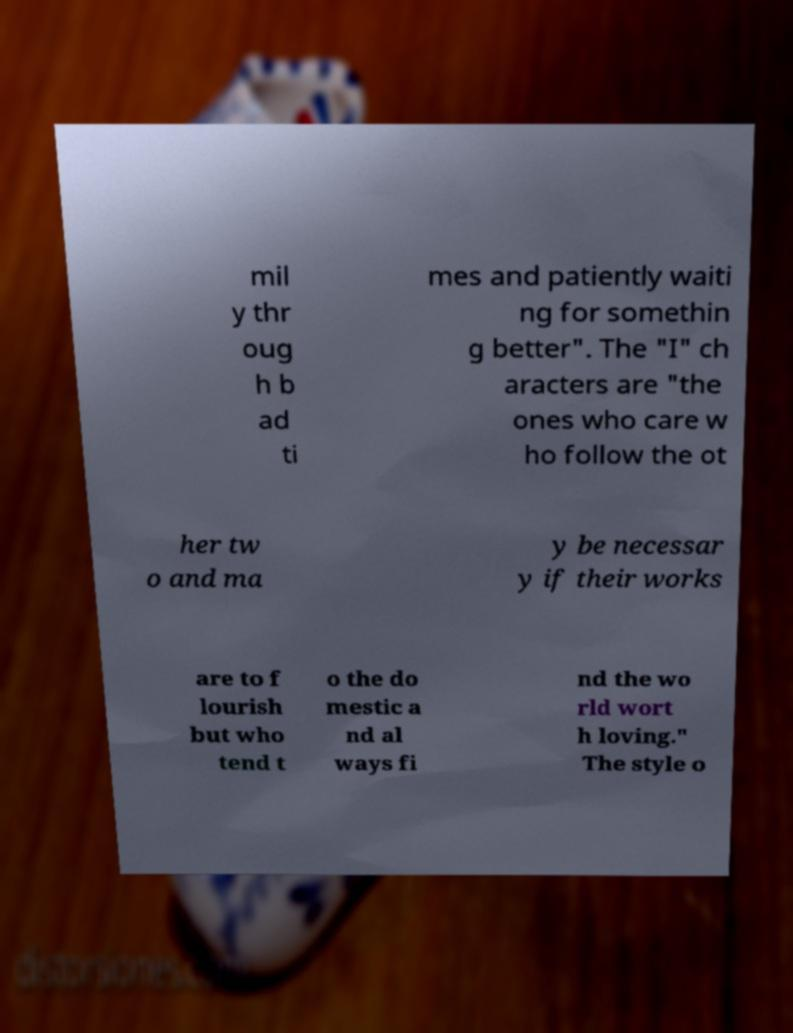For documentation purposes, I need the text within this image transcribed. Could you provide that? mil y thr oug h b ad ti mes and patiently waiti ng for somethin g better". The "I" ch aracters are "the ones who care w ho follow the ot her tw o and ma y be necessar y if their works are to f lourish but who tend t o the do mestic a nd al ways fi nd the wo rld wort h loving." The style o 